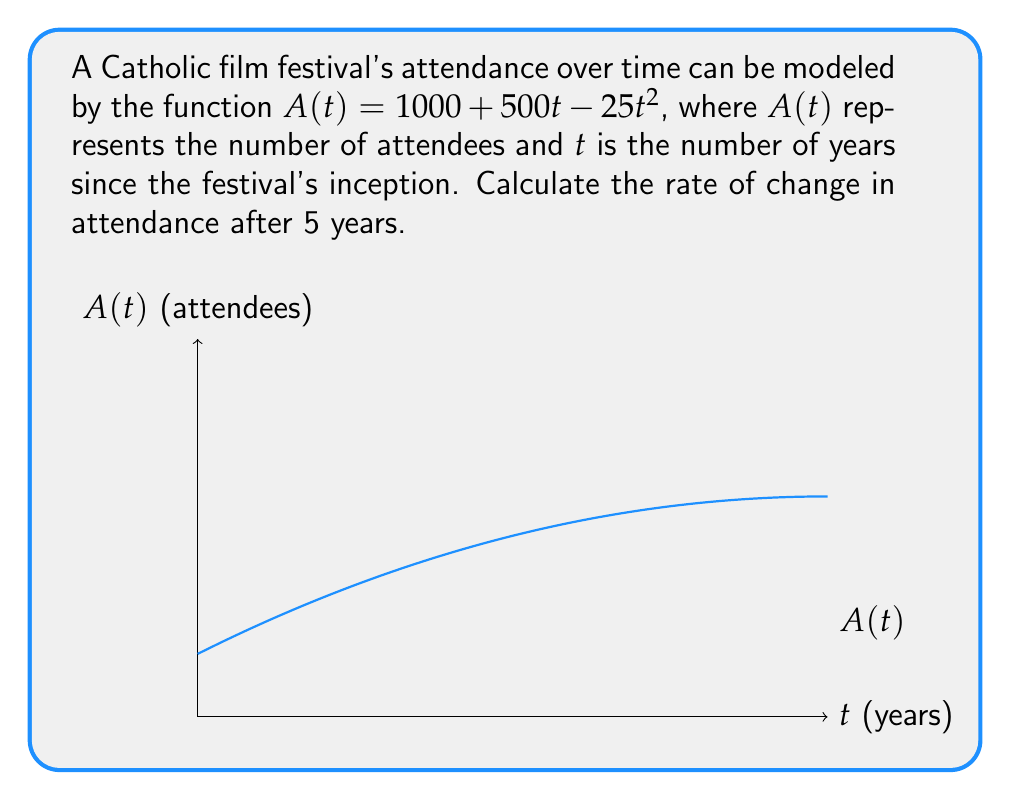What is the answer to this math problem? To find the rate of change in attendance after 5 years, we need to calculate the derivative of $A(t)$ and evaluate it at $t=5$.

Step 1: Find the derivative of $A(t)$.
$$A(t) = 1000 + 500t - 25t^2$$
$$A'(t) = 500 - 50t$$

Step 2: Evaluate $A'(t)$ at $t=5$.
$$A'(5) = 500 - 50(5)$$
$$A'(5) = 500 - 250$$
$$A'(5) = 250$$

The rate of change is 250 attendees per year after 5 years. The positive value indicates that attendance is still increasing, but at a slower rate than initially due to the negative quadratic term in the original function.
Answer: $250$ attendees/year 